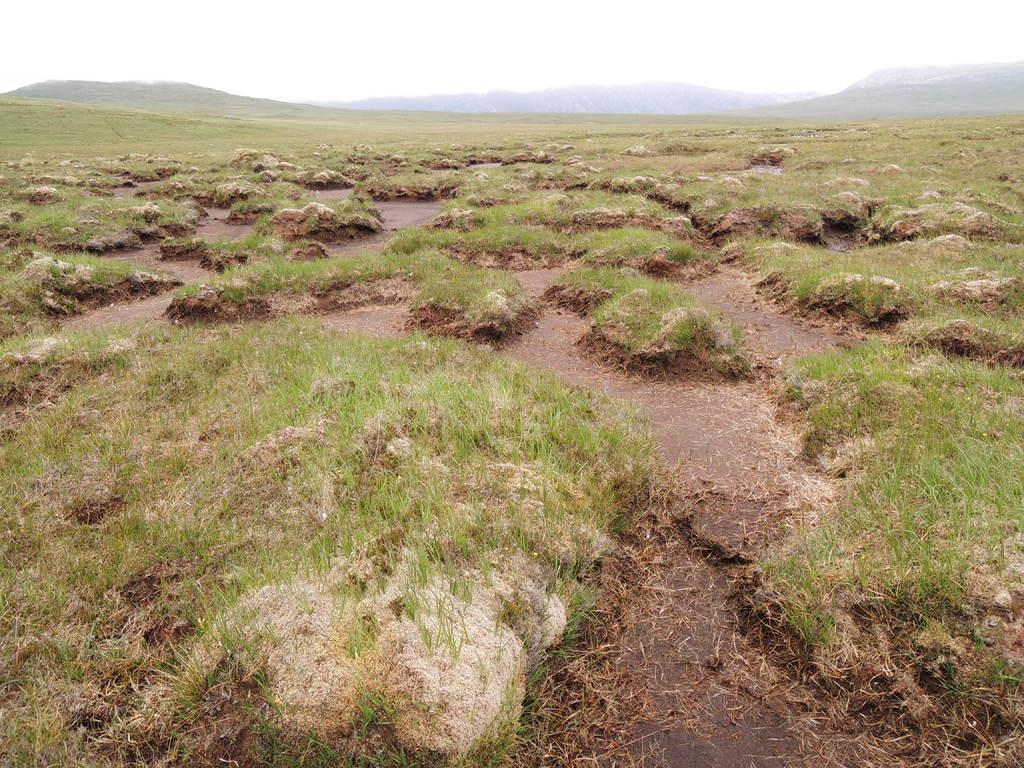Describe this image in one or two sentences. In this picture, we see soil and grass. There are hills in the background. At the top of the picture, we see the sky. 